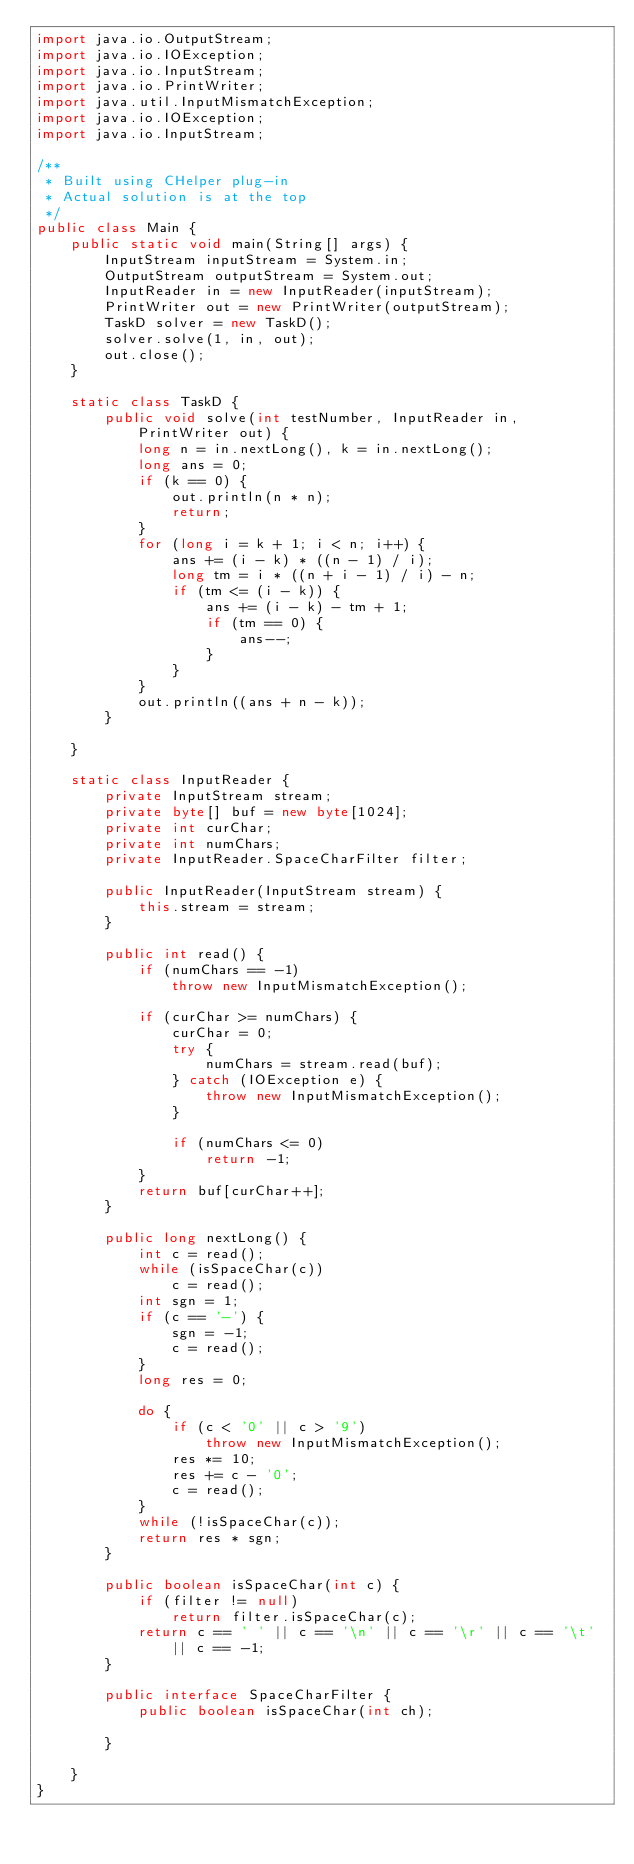Convert code to text. <code><loc_0><loc_0><loc_500><loc_500><_Java_>import java.io.OutputStream;
import java.io.IOException;
import java.io.InputStream;
import java.io.PrintWriter;
import java.util.InputMismatchException;
import java.io.IOException;
import java.io.InputStream;

/**
 * Built using CHelper plug-in
 * Actual solution is at the top
 */
public class Main {
    public static void main(String[] args) {
        InputStream inputStream = System.in;
        OutputStream outputStream = System.out;
        InputReader in = new InputReader(inputStream);
        PrintWriter out = new PrintWriter(outputStream);
        TaskD solver = new TaskD();
        solver.solve(1, in, out);
        out.close();
    }

    static class TaskD {
        public void solve(int testNumber, InputReader in, PrintWriter out) {
            long n = in.nextLong(), k = in.nextLong();
            long ans = 0;
            if (k == 0) {
                out.println(n * n);
                return;
            }
            for (long i = k + 1; i < n; i++) {
                ans += (i - k) * ((n - 1) / i);
                long tm = i * ((n + i - 1) / i) - n;
                if (tm <= (i - k)) {
                    ans += (i - k) - tm + 1;
                    if (tm == 0) {
                        ans--;
                    }
                }
            }
            out.println((ans + n - k));
        }

    }

    static class InputReader {
        private InputStream stream;
        private byte[] buf = new byte[1024];
        private int curChar;
        private int numChars;
        private InputReader.SpaceCharFilter filter;

        public InputReader(InputStream stream) {
            this.stream = stream;
        }

        public int read() {
            if (numChars == -1)
                throw new InputMismatchException();

            if (curChar >= numChars) {
                curChar = 0;
                try {
                    numChars = stream.read(buf);
                } catch (IOException e) {
                    throw new InputMismatchException();
                }

                if (numChars <= 0)
                    return -1;
            }
            return buf[curChar++];
        }

        public long nextLong() {
            int c = read();
            while (isSpaceChar(c))
                c = read();
            int sgn = 1;
            if (c == '-') {
                sgn = -1;
                c = read();
            }
            long res = 0;

            do {
                if (c < '0' || c > '9')
                    throw new InputMismatchException();
                res *= 10;
                res += c - '0';
                c = read();
            }
            while (!isSpaceChar(c));
            return res * sgn;
        }

        public boolean isSpaceChar(int c) {
            if (filter != null)
                return filter.isSpaceChar(c);
            return c == ' ' || c == '\n' || c == '\r' || c == '\t' || c == -1;
        }

        public interface SpaceCharFilter {
            public boolean isSpaceChar(int ch);

        }

    }
}

</code> 